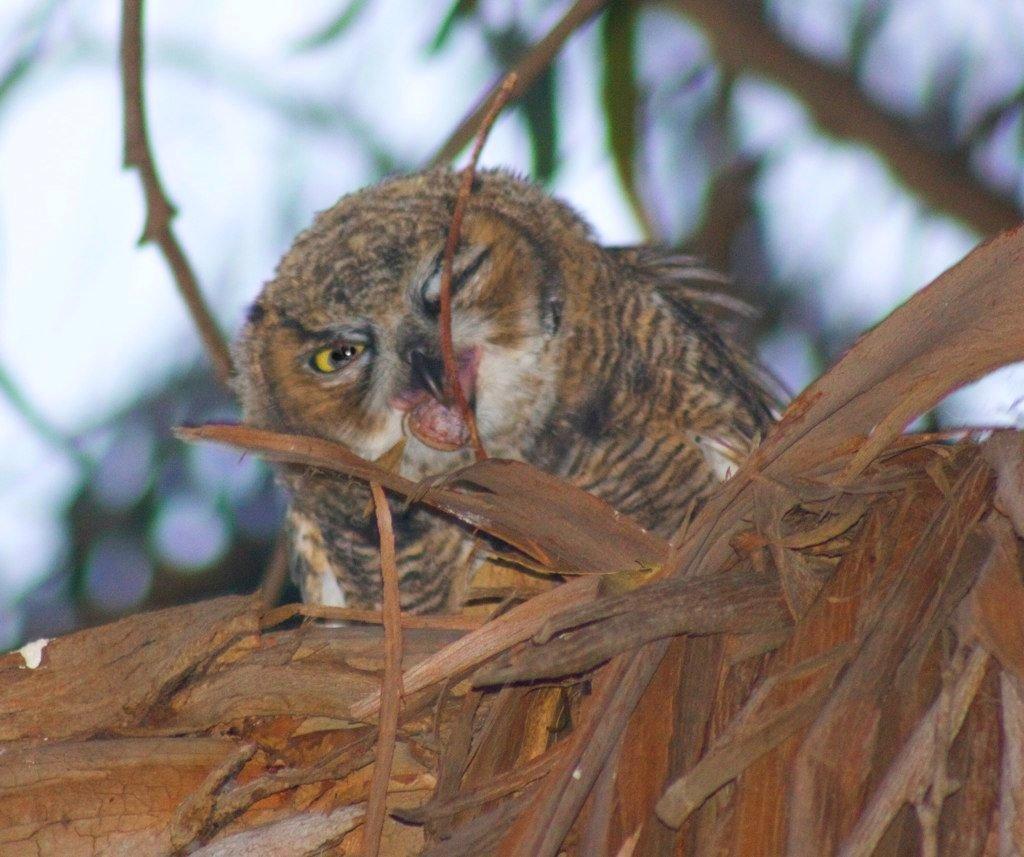Can you describe this image briefly? In the image we can see there is an owl sitting on the tree trunk and background of the image is blurred. 